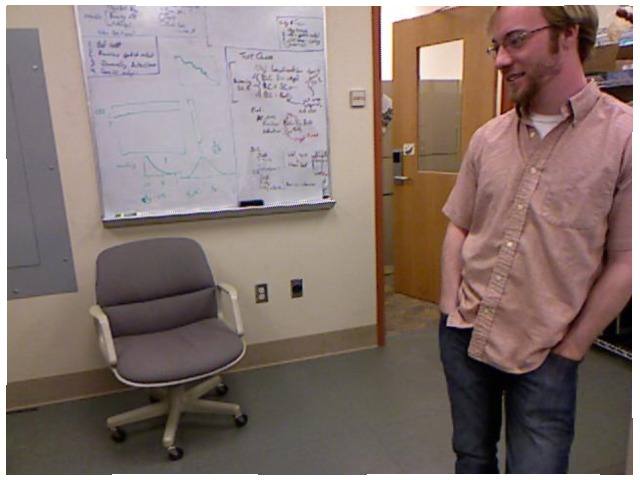<image>
Can you confirm if the man is under the chair? No. The man is not positioned under the chair. The vertical relationship between these objects is different. Is the chair on the wall? No. The chair is not positioned on the wall. They may be near each other, but the chair is not supported by or resting on top of the wall. Is the board behind the chair? Yes. From this viewpoint, the board is positioned behind the chair, with the chair partially or fully occluding the board. 